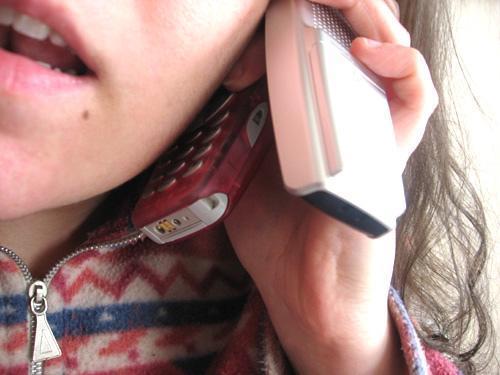How many devices is the woman holding?
Give a very brief answer. 2. How many cell phones are in the picture?
Give a very brief answer. 2. 